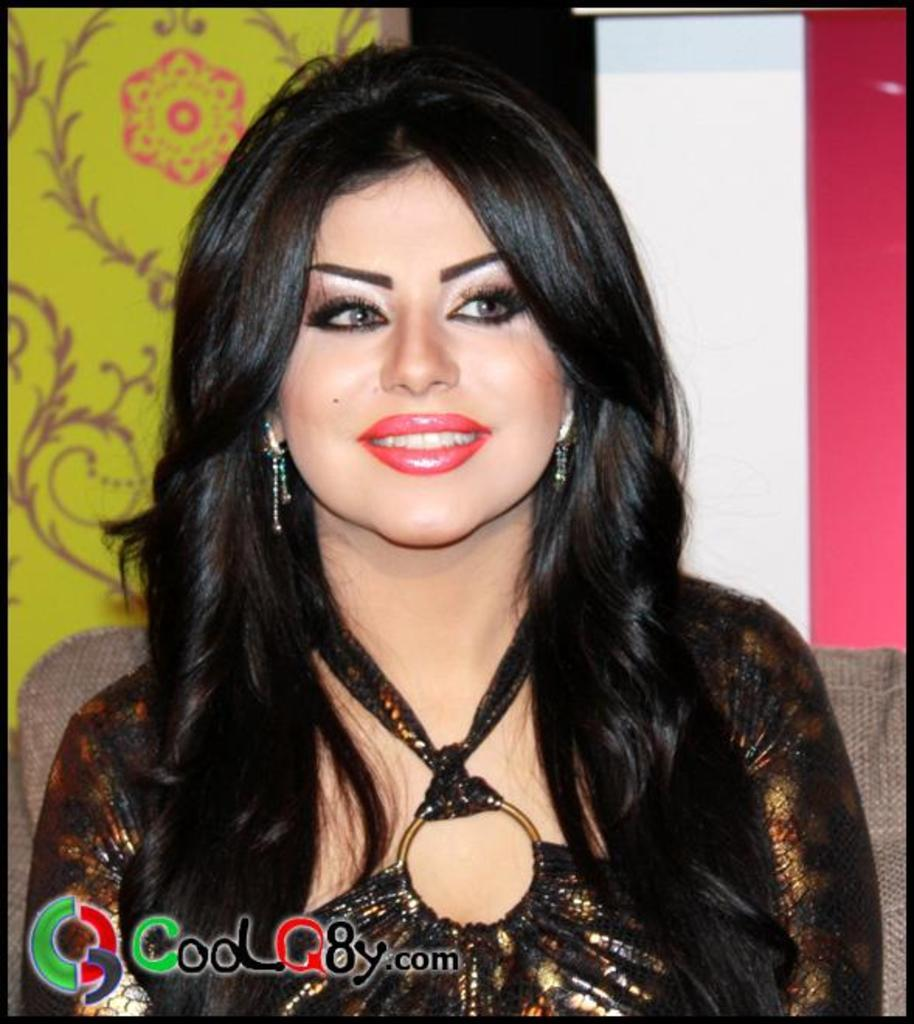Who is present in the image? There is a lady in the image. What is the lady doing in the image? The lady is smiling in the image. What can be seen in the background of the image? There is a wall with designs in the background of the image. Is there any additional information about the image itself? Yes, there is a watermark at the bottom of the image. What type of yarn is the lady using to hear the music in the image? There is no yarn or music present in the image, and the lady is not using any yarn to hear anything. 